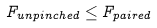Convert formula to latex. <formula><loc_0><loc_0><loc_500><loc_500>F _ { u n p i n c h e d } \leq F _ { p a i r e d }</formula> 